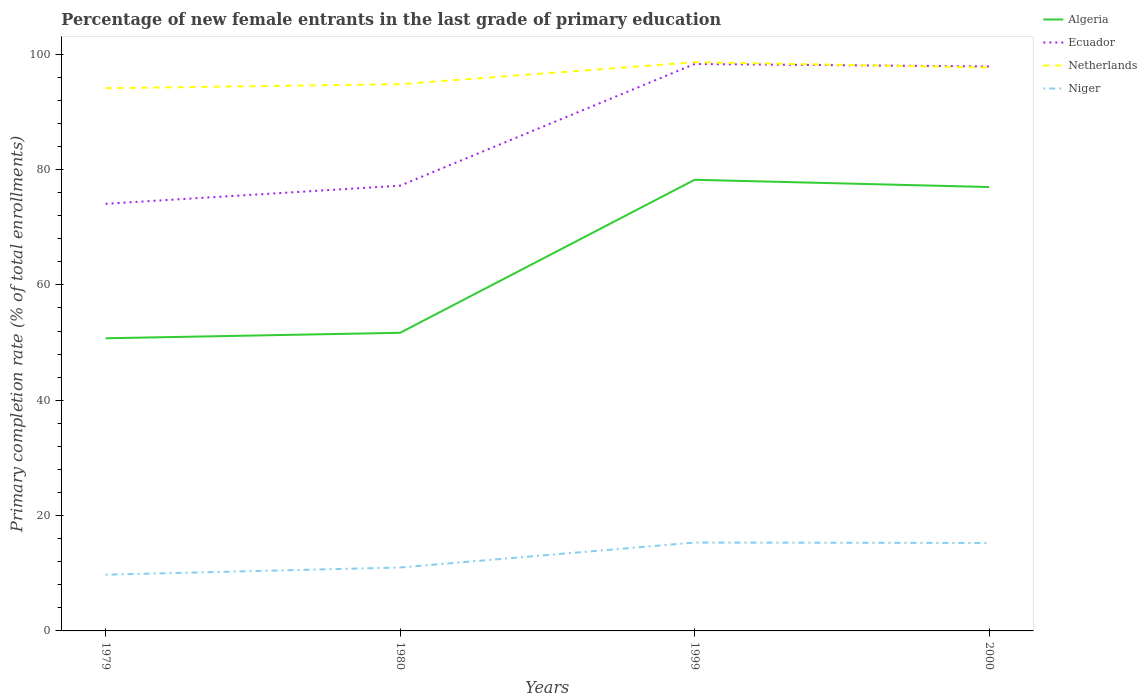Is the number of lines equal to the number of legend labels?
Provide a succinct answer. Yes. Across all years, what is the maximum percentage of new female entrants in Netherlands?
Offer a very short reply. 94.11. In which year was the percentage of new female entrants in Niger maximum?
Give a very brief answer. 1979. What is the total percentage of new female entrants in Niger in the graph?
Your response must be concise. -4.25. What is the difference between the highest and the second highest percentage of new female entrants in Ecuador?
Offer a terse response. 24.24. Is the percentage of new female entrants in Algeria strictly greater than the percentage of new female entrants in Niger over the years?
Keep it short and to the point. No. How many lines are there?
Ensure brevity in your answer.  4. What is the difference between two consecutive major ticks on the Y-axis?
Your answer should be compact. 20. Are the values on the major ticks of Y-axis written in scientific E-notation?
Your response must be concise. No. Does the graph contain any zero values?
Your response must be concise. No. Does the graph contain grids?
Offer a very short reply. No. Where does the legend appear in the graph?
Your answer should be very brief. Top right. What is the title of the graph?
Your answer should be very brief. Percentage of new female entrants in the last grade of primary education. What is the label or title of the X-axis?
Offer a very short reply. Years. What is the label or title of the Y-axis?
Your answer should be very brief. Primary completion rate (% of total enrollments). What is the Primary completion rate (% of total enrollments) of Algeria in 1979?
Give a very brief answer. 50.75. What is the Primary completion rate (% of total enrollments) in Ecuador in 1979?
Ensure brevity in your answer.  74.07. What is the Primary completion rate (% of total enrollments) in Netherlands in 1979?
Offer a terse response. 94.11. What is the Primary completion rate (% of total enrollments) in Niger in 1979?
Keep it short and to the point. 9.75. What is the Primary completion rate (% of total enrollments) of Algeria in 1980?
Your response must be concise. 51.7. What is the Primary completion rate (% of total enrollments) of Ecuador in 1980?
Give a very brief answer. 77.21. What is the Primary completion rate (% of total enrollments) in Netherlands in 1980?
Provide a succinct answer. 94.81. What is the Primary completion rate (% of total enrollments) of Niger in 1980?
Make the answer very short. 11. What is the Primary completion rate (% of total enrollments) in Algeria in 1999?
Your response must be concise. 78.23. What is the Primary completion rate (% of total enrollments) of Ecuador in 1999?
Give a very brief answer. 98.31. What is the Primary completion rate (% of total enrollments) in Netherlands in 1999?
Ensure brevity in your answer.  98.62. What is the Primary completion rate (% of total enrollments) in Niger in 1999?
Make the answer very short. 15.32. What is the Primary completion rate (% of total enrollments) of Algeria in 2000?
Offer a very short reply. 76.98. What is the Primary completion rate (% of total enrollments) in Ecuador in 2000?
Provide a succinct answer. 97.88. What is the Primary completion rate (% of total enrollments) in Netherlands in 2000?
Make the answer very short. 97.7. What is the Primary completion rate (% of total enrollments) in Niger in 2000?
Keep it short and to the point. 15.25. Across all years, what is the maximum Primary completion rate (% of total enrollments) of Algeria?
Your answer should be very brief. 78.23. Across all years, what is the maximum Primary completion rate (% of total enrollments) in Ecuador?
Ensure brevity in your answer.  98.31. Across all years, what is the maximum Primary completion rate (% of total enrollments) in Netherlands?
Ensure brevity in your answer.  98.62. Across all years, what is the maximum Primary completion rate (% of total enrollments) in Niger?
Make the answer very short. 15.32. Across all years, what is the minimum Primary completion rate (% of total enrollments) of Algeria?
Your answer should be very brief. 50.75. Across all years, what is the minimum Primary completion rate (% of total enrollments) of Ecuador?
Your answer should be very brief. 74.07. Across all years, what is the minimum Primary completion rate (% of total enrollments) in Netherlands?
Your answer should be compact. 94.11. Across all years, what is the minimum Primary completion rate (% of total enrollments) in Niger?
Offer a terse response. 9.75. What is the total Primary completion rate (% of total enrollments) in Algeria in the graph?
Your answer should be compact. 257.65. What is the total Primary completion rate (% of total enrollments) in Ecuador in the graph?
Ensure brevity in your answer.  347.47. What is the total Primary completion rate (% of total enrollments) in Netherlands in the graph?
Provide a short and direct response. 385.24. What is the total Primary completion rate (% of total enrollments) in Niger in the graph?
Give a very brief answer. 51.32. What is the difference between the Primary completion rate (% of total enrollments) in Algeria in 1979 and that in 1980?
Provide a short and direct response. -0.95. What is the difference between the Primary completion rate (% of total enrollments) in Ecuador in 1979 and that in 1980?
Your response must be concise. -3.14. What is the difference between the Primary completion rate (% of total enrollments) in Netherlands in 1979 and that in 1980?
Ensure brevity in your answer.  -0.7. What is the difference between the Primary completion rate (% of total enrollments) in Niger in 1979 and that in 1980?
Your response must be concise. -1.25. What is the difference between the Primary completion rate (% of total enrollments) in Algeria in 1979 and that in 1999?
Your response must be concise. -27.48. What is the difference between the Primary completion rate (% of total enrollments) of Ecuador in 1979 and that in 1999?
Your answer should be very brief. -24.24. What is the difference between the Primary completion rate (% of total enrollments) in Netherlands in 1979 and that in 1999?
Give a very brief answer. -4.51. What is the difference between the Primary completion rate (% of total enrollments) of Niger in 1979 and that in 1999?
Ensure brevity in your answer.  -5.58. What is the difference between the Primary completion rate (% of total enrollments) of Algeria in 1979 and that in 2000?
Offer a terse response. -26.23. What is the difference between the Primary completion rate (% of total enrollments) in Ecuador in 1979 and that in 2000?
Keep it short and to the point. -23.82. What is the difference between the Primary completion rate (% of total enrollments) in Netherlands in 1979 and that in 2000?
Give a very brief answer. -3.58. What is the difference between the Primary completion rate (% of total enrollments) in Niger in 1979 and that in 2000?
Your response must be concise. -5.5. What is the difference between the Primary completion rate (% of total enrollments) in Algeria in 1980 and that in 1999?
Your response must be concise. -26.54. What is the difference between the Primary completion rate (% of total enrollments) in Ecuador in 1980 and that in 1999?
Your answer should be compact. -21.1. What is the difference between the Primary completion rate (% of total enrollments) of Netherlands in 1980 and that in 1999?
Provide a short and direct response. -3.81. What is the difference between the Primary completion rate (% of total enrollments) of Niger in 1980 and that in 1999?
Offer a very short reply. -4.32. What is the difference between the Primary completion rate (% of total enrollments) in Algeria in 1980 and that in 2000?
Keep it short and to the point. -25.28. What is the difference between the Primary completion rate (% of total enrollments) of Ecuador in 1980 and that in 2000?
Make the answer very short. -20.67. What is the difference between the Primary completion rate (% of total enrollments) of Netherlands in 1980 and that in 2000?
Your answer should be very brief. -2.89. What is the difference between the Primary completion rate (% of total enrollments) in Niger in 1980 and that in 2000?
Provide a succinct answer. -4.25. What is the difference between the Primary completion rate (% of total enrollments) in Algeria in 1999 and that in 2000?
Offer a terse response. 1.26. What is the difference between the Primary completion rate (% of total enrollments) in Ecuador in 1999 and that in 2000?
Keep it short and to the point. 0.43. What is the difference between the Primary completion rate (% of total enrollments) of Netherlands in 1999 and that in 2000?
Ensure brevity in your answer.  0.92. What is the difference between the Primary completion rate (% of total enrollments) of Niger in 1999 and that in 2000?
Your answer should be compact. 0.07. What is the difference between the Primary completion rate (% of total enrollments) of Algeria in 1979 and the Primary completion rate (% of total enrollments) of Ecuador in 1980?
Offer a very short reply. -26.46. What is the difference between the Primary completion rate (% of total enrollments) of Algeria in 1979 and the Primary completion rate (% of total enrollments) of Netherlands in 1980?
Provide a short and direct response. -44.06. What is the difference between the Primary completion rate (% of total enrollments) of Algeria in 1979 and the Primary completion rate (% of total enrollments) of Niger in 1980?
Give a very brief answer. 39.75. What is the difference between the Primary completion rate (% of total enrollments) of Ecuador in 1979 and the Primary completion rate (% of total enrollments) of Netherlands in 1980?
Provide a short and direct response. -20.74. What is the difference between the Primary completion rate (% of total enrollments) in Ecuador in 1979 and the Primary completion rate (% of total enrollments) in Niger in 1980?
Offer a very short reply. 63.07. What is the difference between the Primary completion rate (% of total enrollments) in Netherlands in 1979 and the Primary completion rate (% of total enrollments) in Niger in 1980?
Ensure brevity in your answer.  83.11. What is the difference between the Primary completion rate (% of total enrollments) of Algeria in 1979 and the Primary completion rate (% of total enrollments) of Ecuador in 1999?
Ensure brevity in your answer.  -47.56. What is the difference between the Primary completion rate (% of total enrollments) of Algeria in 1979 and the Primary completion rate (% of total enrollments) of Netherlands in 1999?
Provide a short and direct response. -47.87. What is the difference between the Primary completion rate (% of total enrollments) in Algeria in 1979 and the Primary completion rate (% of total enrollments) in Niger in 1999?
Make the answer very short. 35.42. What is the difference between the Primary completion rate (% of total enrollments) in Ecuador in 1979 and the Primary completion rate (% of total enrollments) in Netherlands in 1999?
Offer a terse response. -24.55. What is the difference between the Primary completion rate (% of total enrollments) of Ecuador in 1979 and the Primary completion rate (% of total enrollments) of Niger in 1999?
Provide a short and direct response. 58.74. What is the difference between the Primary completion rate (% of total enrollments) in Netherlands in 1979 and the Primary completion rate (% of total enrollments) in Niger in 1999?
Ensure brevity in your answer.  78.79. What is the difference between the Primary completion rate (% of total enrollments) of Algeria in 1979 and the Primary completion rate (% of total enrollments) of Ecuador in 2000?
Your answer should be compact. -47.14. What is the difference between the Primary completion rate (% of total enrollments) of Algeria in 1979 and the Primary completion rate (% of total enrollments) of Netherlands in 2000?
Provide a succinct answer. -46.95. What is the difference between the Primary completion rate (% of total enrollments) in Algeria in 1979 and the Primary completion rate (% of total enrollments) in Niger in 2000?
Offer a very short reply. 35.5. What is the difference between the Primary completion rate (% of total enrollments) of Ecuador in 1979 and the Primary completion rate (% of total enrollments) of Netherlands in 2000?
Your answer should be compact. -23.63. What is the difference between the Primary completion rate (% of total enrollments) of Ecuador in 1979 and the Primary completion rate (% of total enrollments) of Niger in 2000?
Make the answer very short. 58.82. What is the difference between the Primary completion rate (% of total enrollments) of Netherlands in 1979 and the Primary completion rate (% of total enrollments) of Niger in 2000?
Provide a short and direct response. 78.86. What is the difference between the Primary completion rate (% of total enrollments) in Algeria in 1980 and the Primary completion rate (% of total enrollments) in Ecuador in 1999?
Provide a succinct answer. -46.61. What is the difference between the Primary completion rate (% of total enrollments) in Algeria in 1980 and the Primary completion rate (% of total enrollments) in Netherlands in 1999?
Provide a succinct answer. -46.92. What is the difference between the Primary completion rate (% of total enrollments) of Algeria in 1980 and the Primary completion rate (% of total enrollments) of Niger in 1999?
Your answer should be very brief. 36.37. What is the difference between the Primary completion rate (% of total enrollments) of Ecuador in 1980 and the Primary completion rate (% of total enrollments) of Netherlands in 1999?
Your answer should be very brief. -21.41. What is the difference between the Primary completion rate (% of total enrollments) of Ecuador in 1980 and the Primary completion rate (% of total enrollments) of Niger in 1999?
Offer a very short reply. 61.89. What is the difference between the Primary completion rate (% of total enrollments) of Netherlands in 1980 and the Primary completion rate (% of total enrollments) of Niger in 1999?
Ensure brevity in your answer.  79.49. What is the difference between the Primary completion rate (% of total enrollments) of Algeria in 1980 and the Primary completion rate (% of total enrollments) of Ecuador in 2000?
Give a very brief answer. -46.19. What is the difference between the Primary completion rate (% of total enrollments) of Algeria in 1980 and the Primary completion rate (% of total enrollments) of Netherlands in 2000?
Give a very brief answer. -46. What is the difference between the Primary completion rate (% of total enrollments) of Algeria in 1980 and the Primary completion rate (% of total enrollments) of Niger in 2000?
Offer a very short reply. 36.45. What is the difference between the Primary completion rate (% of total enrollments) of Ecuador in 1980 and the Primary completion rate (% of total enrollments) of Netherlands in 2000?
Provide a short and direct response. -20.49. What is the difference between the Primary completion rate (% of total enrollments) of Ecuador in 1980 and the Primary completion rate (% of total enrollments) of Niger in 2000?
Offer a very short reply. 61.96. What is the difference between the Primary completion rate (% of total enrollments) in Netherlands in 1980 and the Primary completion rate (% of total enrollments) in Niger in 2000?
Your response must be concise. 79.56. What is the difference between the Primary completion rate (% of total enrollments) of Algeria in 1999 and the Primary completion rate (% of total enrollments) of Ecuador in 2000?
Make the answer very short. -19.65. What is the difference between the Primary completion rate (% of total enrollments) of Algeria in 1999 and the Primary completion rate (% of total enrollments) of Netherlands in 2000?
Give a very brief answer. -19.47. What is the difference between the Primary completion rate (% of total enrollments) of Algeria in 1999 and the Primary completion rate (% of total enrollments) of Niger in 2000?
Your response must be concise. 62.98. What is the difference between the Primary completion rate (% of total enrollments) in Ecuador in 1999 and the Primary completion rate (% of total enrollments) in Netherlands in 2000?
Keep it short and to the point. 0.61. What is the difference between the Primary completion rate (% of total enrollments) in Ecuador in 1999 and the Primary completion rate (% of total enrollments) in Niger in 2000?
Provide a short and direct response. 83.06. What is the difference between the Primary completion rate (% of total enrollments) of Netherlands in 1999 and the Primary completion rate (% of total enrollments) of Niger in 2000?
Keep it short and to the point. 83.37. What is the average Primary completion rate (% of total enrollments) of Algeria per year?
Make the answer very short. 64.41. What is the average Primary completion rate (% of total enrollments) of Ecuador per year?
Keep it short and to the point. 86.87. What is the average Primary completion rate (% of total enrollments) of Netherlands per year?
Your response must be concise. 96.31. What is the average Primary completion rate (% of total enrollments) of Niger per year?
Provide a short and direct response. 12.83. In the year 1979, what is the difference between the Primary completion rate (% of total enrollments) of Algeria and Primary completion rate (% of total enrollments) of Ecuador?
Your answer should be very brief. -23.32. In the year 1979, what is the difference between the Primary completion rate (% of total enrollments) of Algeria and Primary completion rate (% of total enrollments) of Netherlands?
Your answer should be very brief. -43.37. In the year 1979, what is the difference between the Primary completion rate (% of total enrollments) of Algeria and Primary completion rate (% of total enrollments) of Niger?
Ensure brevity in your answer.  41. In the year 1979, what is the difference between the Primary completion rate (% of total enrollments) in Ecuador and Primary completion rate (% of total enrollments) in Netherlands?
Provide a succinct answer. -20.05. In the year 1979, what is the difference between the Primary completion rate (% of total enrollments) of Ecuador and Primary completion rate (% of total enrollments) of Niger?
Provide a succinct answer. 64.32. In the year 1979, what is the difference between the Primary completion rate (% of total enrollments) of Netherlands and Primary completion rate (% of total enrollments) of Niger?
Offer a very short reply. 84.36. In the year 1980, what is the difference between the Primary completion rate (% of total enrollments) in Algeria and Primary completion rate (% of total enrollments) in Ecuador?
Ensure brevity in your answer.  -25.51. In the year 1980, what is the difference between the Primary completion rate (% of total enrollments) of Algeria and Primary completion rate (% of total enrollments) of Netherlands?
Offer a very short reply. -43.11. In the year 1980, what is the difference between the Primary completion rate (% of total enrollments) in Algeria and Primary completion rate (% of total enrollments) in Niger?
Give a very brief answer. 40.7. In the year 1980, what is the difference between the Primary completion rate (% of total enrollments) of Ecuador and Primary completion rate (% of total enrollments) of Netherlands?
Provide a short and direct response. -17.6. In the year 1980, what is the difference between the Primary completion rate (% of total enrollments) in Ecuador and Primary completion rate (% of total enrollments) in Niger?
Provide a succinct answer. 66.21. In the year 1980, what is the difference between the Primary completion rate (% of total enrollments) of Netherlands and Primary completion rate (% of total enrollments) of Niger?
Ensure brevity in your answer.  83.81. In the year 1999, what is the difference between the Primary completion rate (% of total enrollments) in Algeria and Primary completion rate (% of total enrollments) in Ecuador?
Keep it short and to the point. -20.08. In the year 1999, what is the difference between the Primary completion rate (% of total enrollments) of Algeria and Primary completion rate (% of total enrollments) of Netherlands?
Ensure brevity in your answer.  -20.39. In the year 1999, what is the difference between the Primary completion rate (% of total enrollments) of Algeria and Primary completion rate (% of total enrollments) of Niger?
Your answer should be very brief. 62.91. In the year 1999, what is the difference between the Primary completion rate (% of total enrollments) in Ecuador and Primary completion rate (% of total enrollments) in Netherlands?
Provide a succinct answer. -0.31. In the year 1999, what is the difference between the Primary completion rate (% of total enrollments) in Ecuador and Primary completion rate (% of total enrollments) in Niger?
Provide a succinct answer. 82.99. In the year 1999, what is the difference between the Primary completion rate (% of total enrollments) of Netherlands and Primary completion rate (% of total enrollments) of Niger?
Keep it short and to the point. 83.3. In the year 2000, what is the difference between the Primary completion rate (% of total enrollments) in Algeria and Primary completion rate (% of total enrollments) in Ecuador?
Offer a very short reply. -20.91. In the year 2000, what is the difference between the Primary completion rate (% of total enrollments) of Algeria and Primary completion rate (% of total enrollments) of Netherlands?
Offer a terse response. -20.72. In the year 2000, what is the difference between the Primary completion rate (% of total enrollments) in Algeria and Primary completion rate (% of total enrollments) in Niger?
Make the answer very short. 61.72. In the year 2000, what is the difference between the Primary completion rate (% of total enrollments) of Ecuador and Primary completion rate (% of total enrollments) of Netherlands?
Keep it short and to the point. 0.19. In the year 2000, what is the difference between the Primary completion rate (% of total enrollments) in Ecuador and Primary completion rate (% of total enrollments) in Niger?
Your answer should be very brief. 82.63. In the year 2000, what is the difference between the Primary completion rate (% of total enrollments) in Netherlands and Primary completion rate (% of total enrollments) in Niger?
Give a very brief answer. 82.45. What is the ratio of the Primary completion rate (% of total enrollments) in Algeria in 1979 to that in 1980?
Give a very brief answer. 0.98. What is the ratio of the Primary completion rate (% of total enrollments) in Ecuador in 1979 to that in 1980?
Keep it short and to the point. 0.96. What is the ratio of the Primary completion rate (% of total enrollments) of Netherlands in 1979 to that in 1980?
Provide a short and direct response. 0.99. What is the ratio of the Primary completion rate (% of total enrollments) in Niger in 1979 to that in 1980?
Your answer should be compact. 0.89. What is the ratio of the Primary completion rate (% of total enrollments) in Algeria in 1979 to that in 1999?
Your answer should be very brief. 0.65. What is the ratio of the Primary completion rate (% of total enrollments) in Ecuador in 1979 to that in 1999?
Your response must be concise. 0.75. What is the ratio of the Primary completion rate (% of total enrollments) in Netherlands in 1979 to that in 1999?
Make the answer very short. 0.95. What is the ratio of the Primary completion rate (% of total enrollments) of Niger in 1979 to that in 1999?
Offer a terse response. 0.64. What is the ratio of the Primary completion rate (% of total enrollments) in Algeria in 1979 to that in 2000?
Offer a terse response. 0.66. What is the ratio of the Primary completion rate (% of total enrollments) in Ecuador in 1979 to that in 2000?
Offer a terse response. 0.76. What is the ratio of the Primary completion rate (% of total enrollments) in Netherlands in 1979 to that in 2000?
Your answer should be compact. 0.96. What is the ratio of the Primary completion rate (% of total enrollments) in Niger in 1979 to that in 2000?
Your answer should be very brief. 0.64. What is the ratio of the Primary completion rate (% of total enrollments) in Algeria in 1980 to that in 1999?
Give a very brief answer. 0.66. What is the ratio of the Primary completion rate (% of total enrollments) in Ecuador in 1980 to that in 1999?
Your answer should be very brief. 0.79. What is the ratio of the Primary completion rate (% of total enrollments) of Netherlands in 1980 to that in 1999?
Offer a terse response. 0.96. What is the ratio of the Primary completion rate (% of total enrollments) in Niger in 1980 to that in 1999?
Your response must be concise. 0.72. What is the ratio of the Primary completion rate (% of total enrollments) in Algeria in 1980 to that in 2000?
Offer a very short reply. 0.67. What is the ratio of the Primary completion rate (% of total enrollments) in Ecuador in 1980 to that in 2000?
Your response must be concise. 0.79. What is the ratio of the Primary completion rate (% of total enrollments) in Netherlands in 1980 to that in 2000?
Offer a very short reply. 0.97. What is the ratio of the Primary completion rate (% of total enrollments) in Niger in 1980 to that in 2000?
Offer a very short reply. 0.72. What is the ratio of the Primary completion rate (% of total enrollments) in Algeria in 1999 to that in 2000?
Ensure brevity in your answer.  1.02. What is the ratio of the Primary completion rate (% of total enrollments) in Netherlands in 1999 to that in 2000?
Give a very brief answer. 1.01. What is the ratio of the Primary completion rate (% of total enrollments) of Niger in 1999 to that in 2000?
Keep it short and to the point. 1. What is the difference between the highest and the second highest Primary completion rate (% of total enrollments) of Algeria?
Ensure brevity in your answer.  1.26. What is the difference between the highest and the second highest Primary completion rate (% of total enrollments) of Ecuador?
Ensure brevity in your answer.  0.43. What is the difference between the highest and the second highest Primary completion rate (% of total enrollments) of Netherlands?
Give a very brief answer. 0.92. What is the difference between the highest and the second highest Primary completion rate (% of total enrollments) of Niger?
Keep it short and to the point. 0.07. What is the difference between the highest and the lowest Primary completion rate (% of total enrollments) of Algeria?
Give a very brief answer. 27.48. What is the difference between the highest and the lowest Primary completion rate (% of total enrollments) of Ecuador?
Make the answer very short. 24.24. What is the difference between the highest and the lowest Primary completion rate (% of total enrollments) of Netherlands?
Ensure brevity in your answer.  4.51. What is the difference between the highest and the lowest Primary completion rate (% of total enrollments) in Niger?
Ensure brevity in your answer.  5.58. 